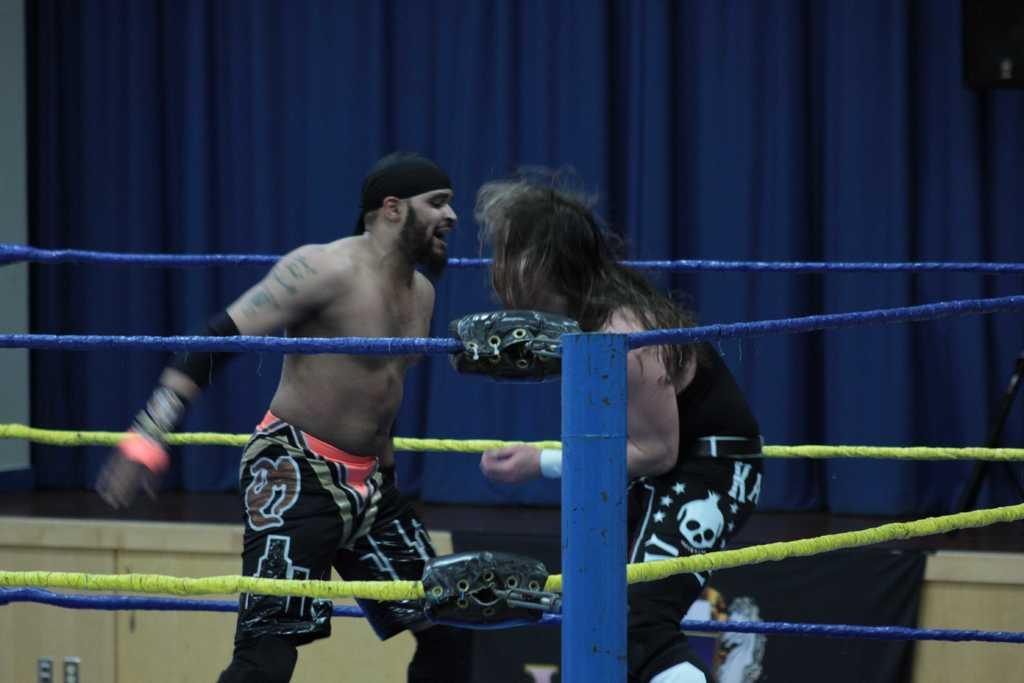How many people are present in the image? There are two people standing in the image. What can be seen in the image besides the people? There is a pole, ropes, a curtain, and a cupboard in the image. Can you describe the pole in the image? The pole is a vertical structure that can be used for support or as an anchor for the ropes. What is visible in the background of the image? There is a curtain and a cupboard in the background of the image. What type of shoes are the people wearing in the image? There is no information about shoes in the image, as the focus is on the pole, ropes, curtain, and cupboard. 